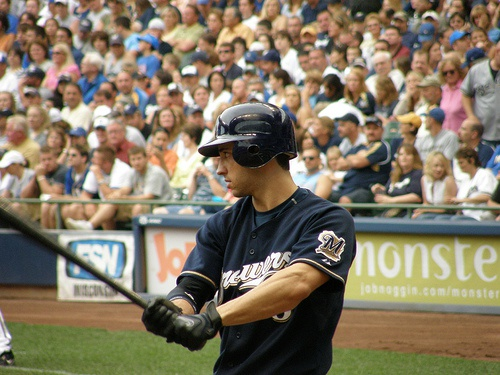Describe the objects in this image and their specific colors. I can see people in salmon, gray, tan, and lightgray tones, people in salmon, black, gray, and maroon tones, people in salmon, darkgray, tan, and lightgray tones, baseball glove in salmon, black, gray, darkgreen, and darkgray tones, and baseball bat in salmon, black, gray, and darkgreen tones in this image. 